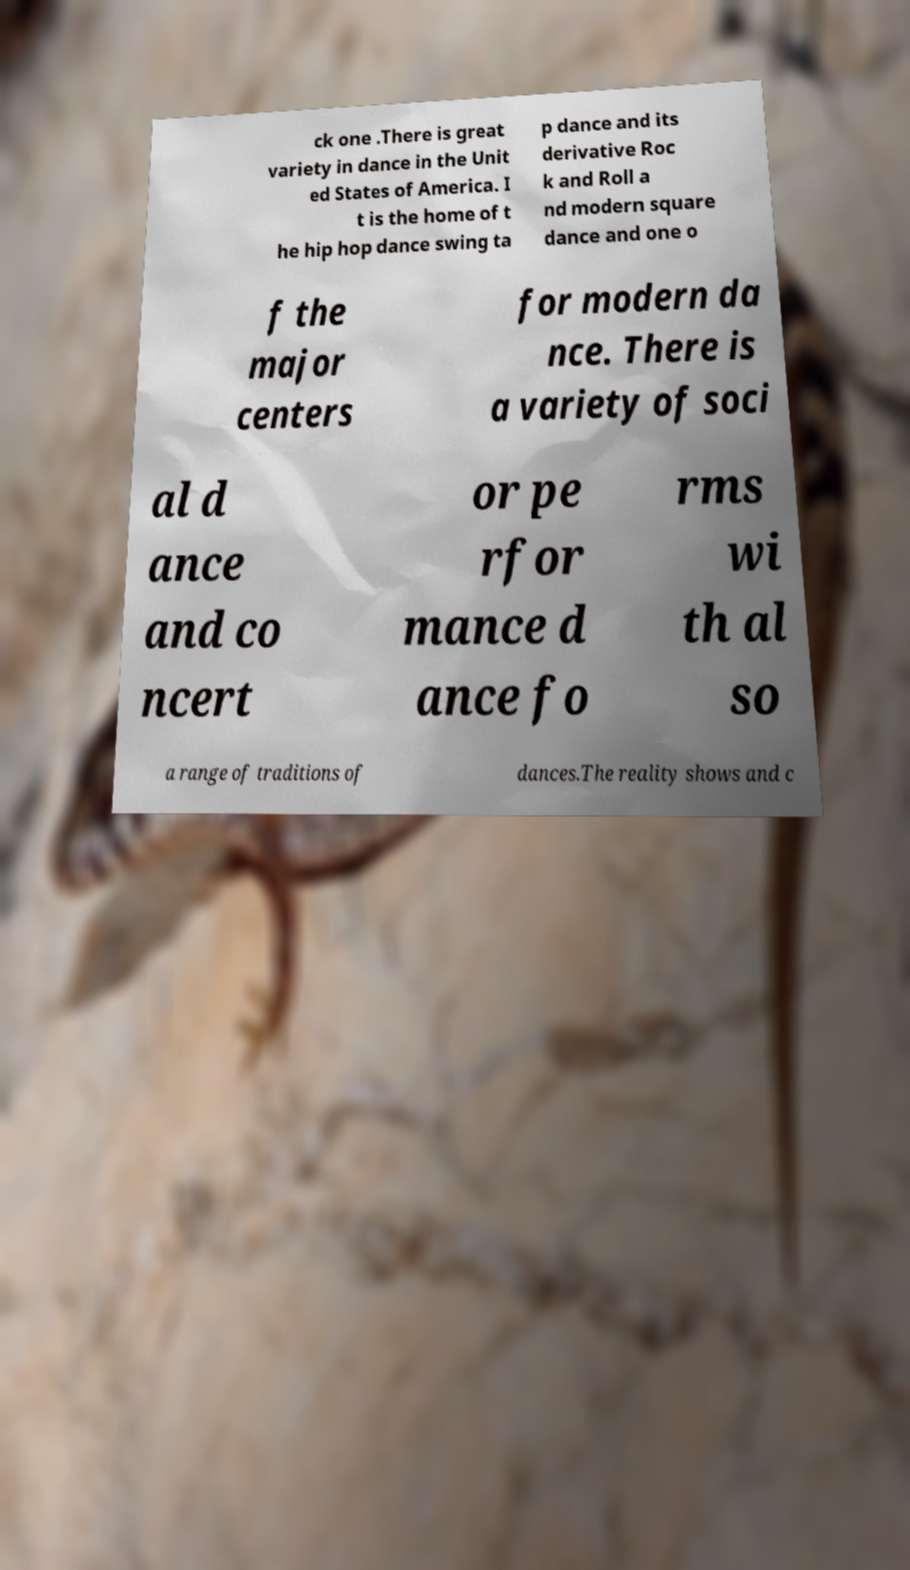There's text embedded in this image that I need extracted. Can you transcribe it verbatim? ck one .There is great variety in dance in the Unit ed States of America. I t is the home of t he hip hop dance swing ta p dance and its derivative Roc k and Roll a nd modern square dance and one o f the major centers for modern da nce. There is a variety of soci al d ance and co ncert or pe rfor mance d ance fo rms wi th al so a range of traditions of dances.The reality shows and c 